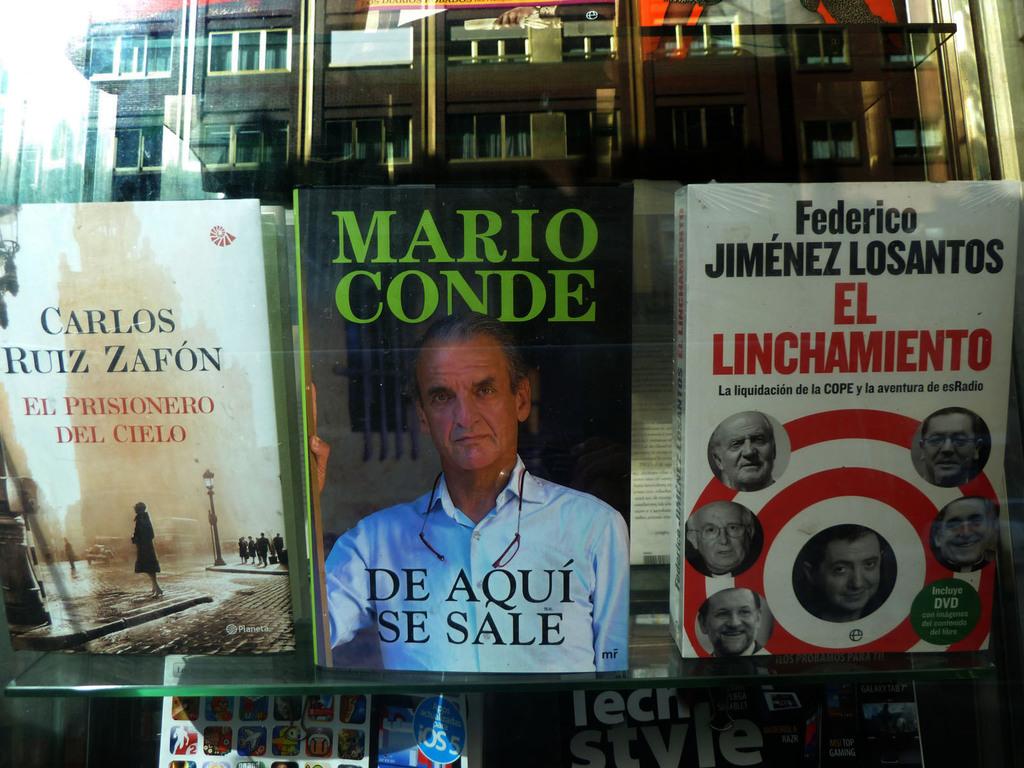Who wrote "de aqui se sale"?
Your answer should be very brief. Mario conde. 